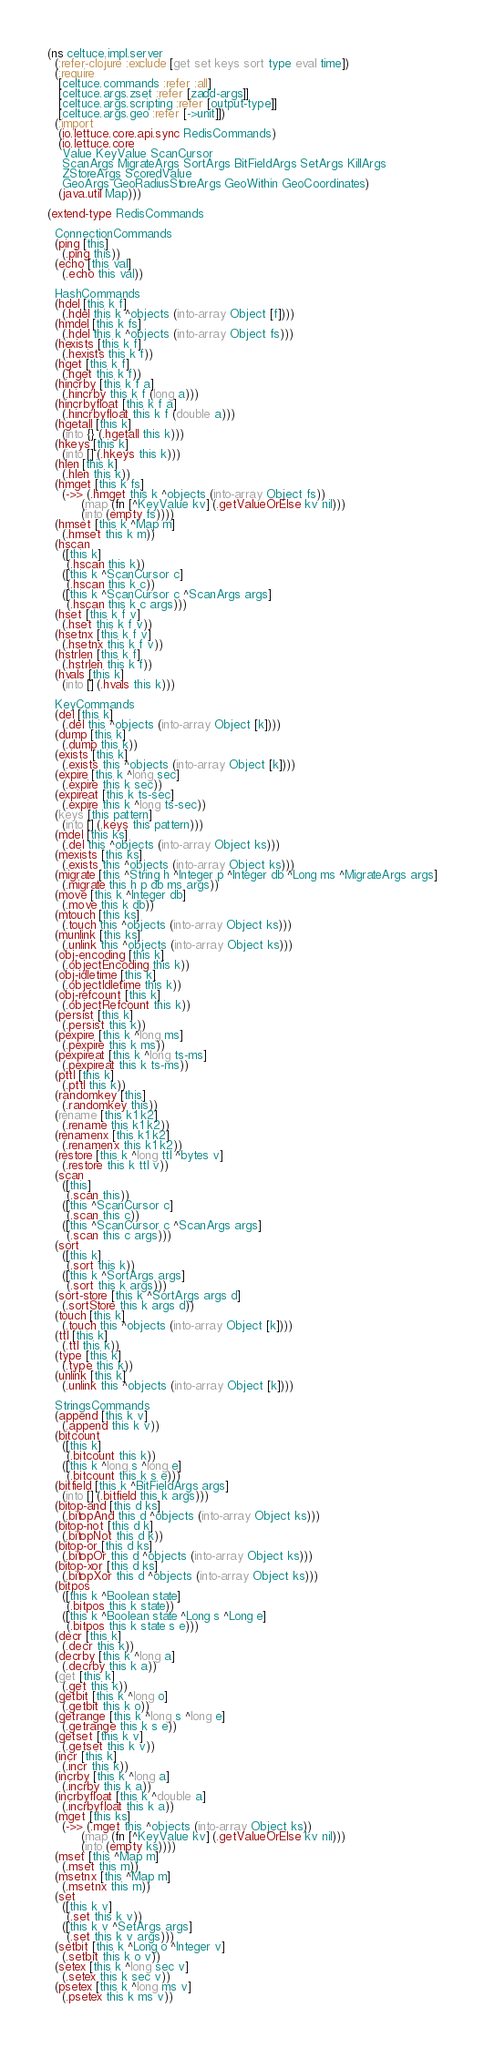<code> <loc_0><loc_0><loc_500><loc_500><_Clojure_>(ns celtuce.impl.server
  (:refer-clojure :exclude [get set keys sort type eval time])
  (:require
   [celtuce.commands :refer :all]
   [celtuce.args.zset :refer [zadd-args]]
   [celtuce.args.scripting :refer [output-type]]
   [celtuce.args.geo :refer [->unit]])
  (:import
   (io.lettuce.core.api.sync RedisCommands)
   (io.lettuce.core
    Value KeyValue ScanCursor
    ScanArgs MigrateArgs SortArgs BitFieldArgs SetArgs KillArgs
    ZStoreArgs ScoredValue
    GeoArgs GeoRadiusStoreArgs GeoWithin GeoCoordinates)
   (java.util Map)))

(extend-type RedisCommands

  ConnectionCommands
  (ping [this]
    (.ping this))
  (echo [this val]
    (.echo this val))

  HashCommands
  (hdel [this k f]
    (.hdel this k ^objects (into-array Object [f])))
  (hmdel [this k fs]
    (.hdel this k ^objects (into-array Object fs)))
  (hexists [this k f]
    (.hexists this k f))
  (hget [this k f]
    (.hget this k f))
  (hincrby [this k f a]
    (.hincrby this k f (long a)))
  (hincrbyfloat [this k f a]
    (.hincrbyfloat this k f (double a)))
  (hgetall [this k]
    (into {} (.hgetall this k)))
  (hkeys [this k]
    (into [] (.hkeys this k)))
  (hlen [this k]
    (.hlen this k))
  (hmget [this k fs]
    (->> (.hmget this k ^objects (into-array Object fs))
         (map (fn [^KeyValue kv] (.getValueOrElse kv nil)))
         (into (empty fs))))
  (hmset [this k ^Map m]
    (.hmset this k m))
  (hscan
    ([this k]
     (.hscan this k))
    ([this k ^ScanCursor c]
     (.hscan this k c))
    ([this k ^ScanCursor c ^ScanArgs args]
     (.hscan this k c args)))
  (hset [this k f v]
    (.hset this k f v))
  (hsetnx [this k f v]
    (.hsetnx this k f v))
  (hstrlen [this k f]
    (.hstrlen this k f))
  (hvals [this k]
    (into [] (.hvals this k)))

  KeyCommands
  (del [this k]
    (.del this ^objects (into-array Object [k])))
  (dump [this k]
    (.dump this k))
  (exists [this k]
    (.exists this ^objects (into-array Object [k])))
  (expire [this k ^long sec]
    (.expire this k sec))
  (expireat [this k ts-sec]
    (.expire this k ^long ts-sec))
  (keys [this pattern]
    (into [] (.keys this pattern)))
  (mdel [this ks]
    (.del this ^objects (into-array Object ks)))
  (mexists [this ks]
    (.exists this ^objects (into-array Object ks)))
  (migrate [this ^String h ^Integer p ^Integer db ^Long ms ^MigrateArgs args]
    (.migrate this h p db ms args))
  (move [this k ^Integer db]
    (.move this k db))
  (mtouch [this ks]
    (.touch this ^objects (into-array Object ks)))
  (munlink [this ks]
    (.unlink this ^objects (into-array Object ks)))
  (obj-encoding [this k]
    (.objectEncoding this k))
  (obj-idletime [this k]
    (.objectIdletime this k))
  (obj-refcount [this k]
    (.objectRefcount this k))
  (persist [this k]
    (.persist this k))
  (pexpire [this k ^long ms]
    (.pexpire this k ms))
  (pexpireat [this k ^long ts-ms]
    (.pexpireat this k ts-ms))
  (pttl [this k]
    (.pttl this k))
  (randomkey [this]
    (.randomkey this))
  (rename [this k1 k2]
    (.rename this k1 k2))
  (renamenx [this k1 k2]
    (.renamenx this k1 k2))
  (restore [this k ^long ttl ^bytes v]
    (.restore this k ttl v))
  (scan
    ([this]
     (.scan this))
    ([this ^ScanCursor c]
     (.scan this c))
    ([this ^ScanCursor c ^ScanArgs args]
     (.scan this c args)))
  (sort
    ([this k]
     (.sort this k))
    ([this k ^SortArgs args]
     (.sort this k args)))
  (sort-store [this k ^SortArgs args d]
    (.sortStore this k args d))
  (touch [this k]
    (.touch this ^objects (into-array Object [k])))
  (ttl [this k]
    (.ttl this k))
  (type [this k]
    (.type this k))
  (unlink [this k]
    (.unlink this ^objects (into-array Object [k])))

  StringsCommands
  (append [this k v]
    (.append this k v))
  (bitcount
    ([this k]
     (.bitcount this k))
    ([this k ^long s ^long e]
     (.bitcount this k s e)))
  (bitfield [this k ^BitFieldArgs args]
    (into [] (.bitfield this k args)))
  (bitop-and [this d ks]
    (.bitopAnd this d ^objects (into-array Object ks)))
  (bitop-not [this d k]
    (.bitopNot this d k))
  (bitop-or [this d ks]
    (.bitopOr this d ^objects (into-array Object ks)))
  (bitop-xor [this d ks]
    (.bitopXor this d ^objects (into-array Object ks)))
  (bitpos
    ([this k ^Boolean state]
     (.bitpos this k state))
    ([this k ^Boolean state ^Long s ^Long e]
     (.bitpos this k state s e)))
  (decr [this k]
    (.decr this k))
  (decrby [this k ^long a]
    (.decrby this k a))
  (get [this k]
    (.get this k))
  (getbit [this k ^long o]
    (.getbit this k o))
  (getrange [this k ^long s ^long e]
    (.getrange this k s e))
  (getset [this k v]
    (.getset this k v))
  (incr [this k]
    (.incr this k))
  (incrby [this k ^long a]
    (.incrby this k a))
  (incrbyfloat [this k ^double a]
    (.incrbyfloat this k a))
  (mget [this ks]
    (->> (.mget this ^objects (into-array Object ks))
         (map (fn [^KeyValue kv] (.getValueOrElse kv nil)))
         (into (empty ks))))
  (mset [this ^Map m]
    (.mset this m))
  (msetnx [this ^Map m]
    (.msetnx this m))
  (set
    ([this k v]
     (.set this k v))
    ([this k v ^SetArgs args]
     (.set this k v args)))
  (setbit [this k ^Long o ^Integer v]
    (.setbit this k o v))
  (setex [this k ^long sec v]
    (.setex this k sec v))
  (psetex [this k ^long ms v]
    (.psetex this k ms v))</code> 